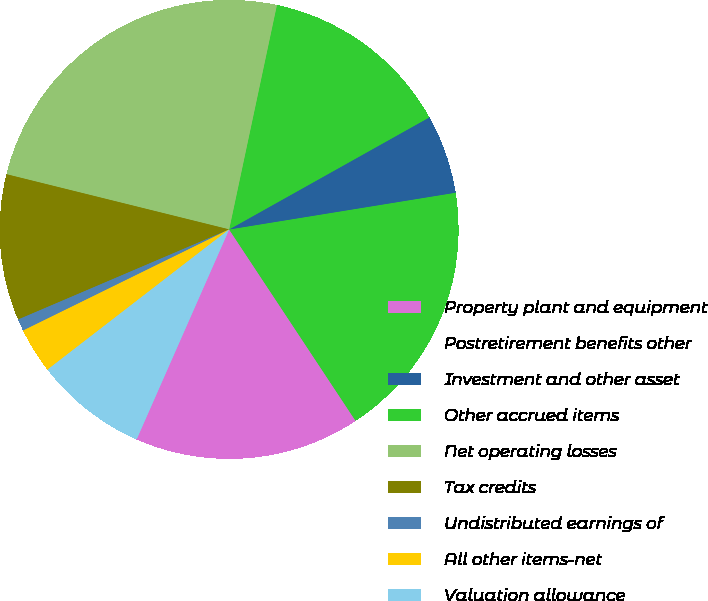Convert chart. <chart><loc_0><loc_0><loc_500><loc_500><pie_chart><fcel>Property plant and equipment<fcel>Postretirement benefits other<fcel>Investment and other asset<fcel>Other accrued items<fcel>Net operating losses<fcel>Tax credits<fcel>Undistributed earnings of<fcel>All other items-net<fcel>Valuation allowance<nl><fcel>15.9%<fcel>18.27%<fcel>5.56%<fcel>13.54%<fcel>24.47%<fcel>10.29%<fcel>0.84%<fcel>3.2%<fcel>7.93%<nl></chart> 